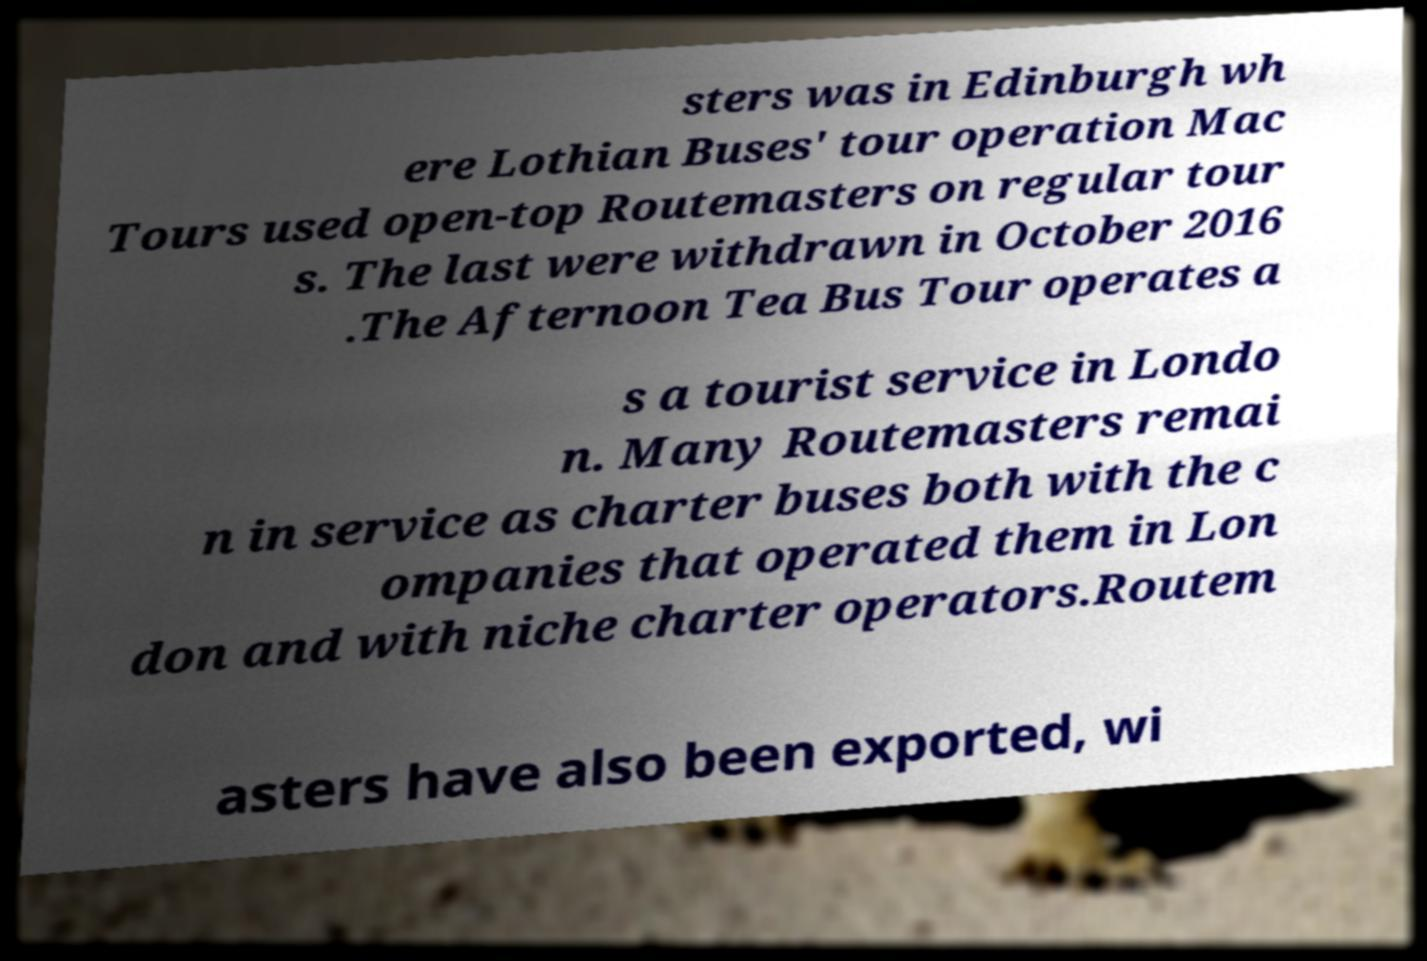Please read and relay the text visible in this image. What does it say? sters was in Edinburgh wh ere Lothian Buses' tour operation Mac Tours used open-top Routemasters on regular tour s. The last were withdrawn in October 2016 .The Afternoon Tea Bus Tour operates a s a tourist service in Londo n. Many Routemasters remai n in service as charter buses both with the c ompanies that operated them in Lon don and with niche charter operators.Routem asters have also been exported, wi 